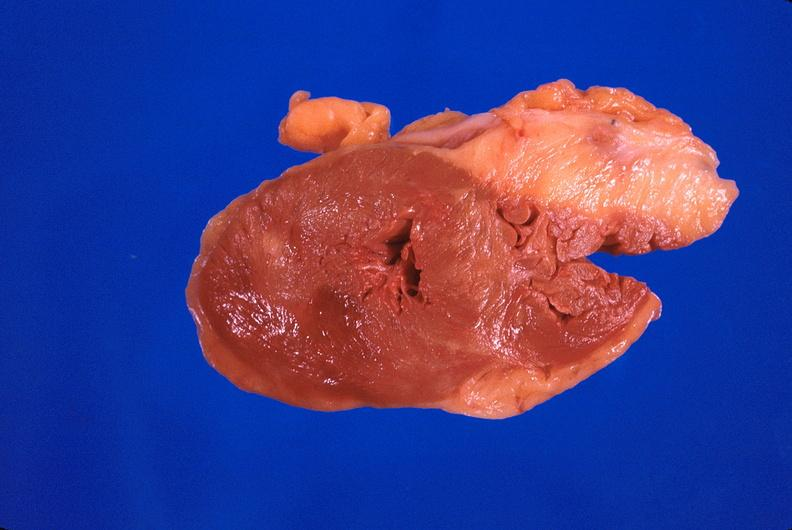what is present?
Answer the question using a single word or phrase. Cardiovascular 